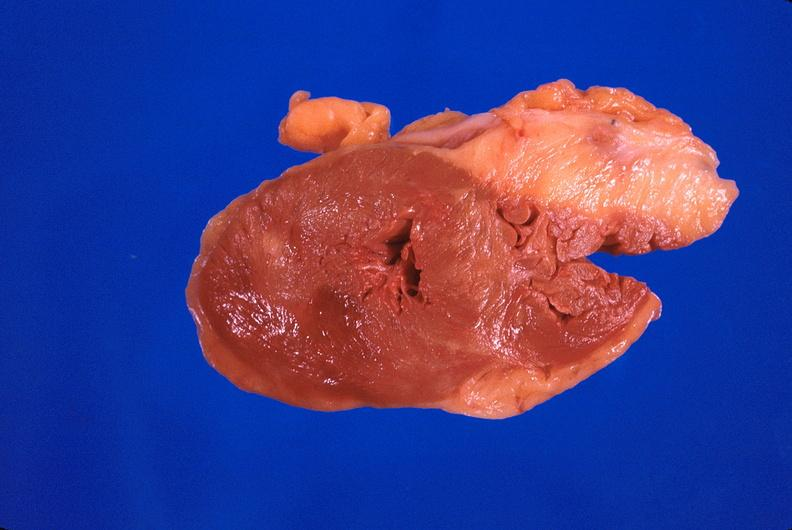what is present?
Answer the question using a single word or phrase. Cardiovascular 